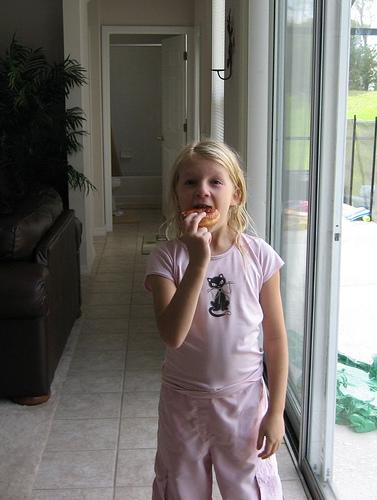What color is the girls outfit?
Short answer required. Pink. Is there a cat on this girls shirt?
Write a very short answer. Yes. What food item is the girl eating?
Keep it brief. Donut. 